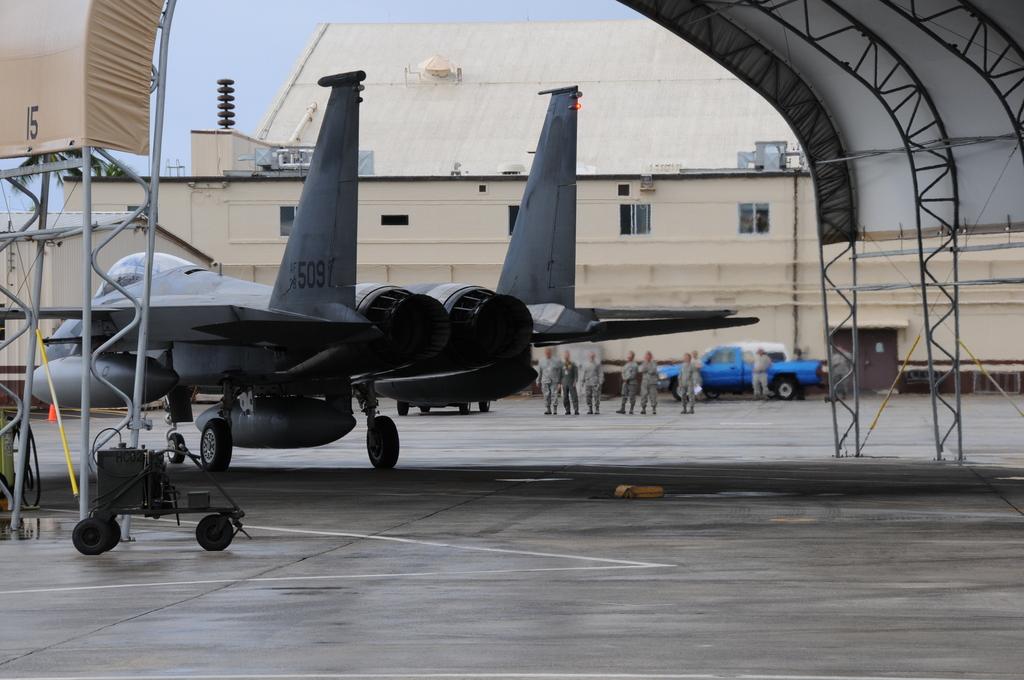What number is at the top left?
Your answer should be very brief. 15. 